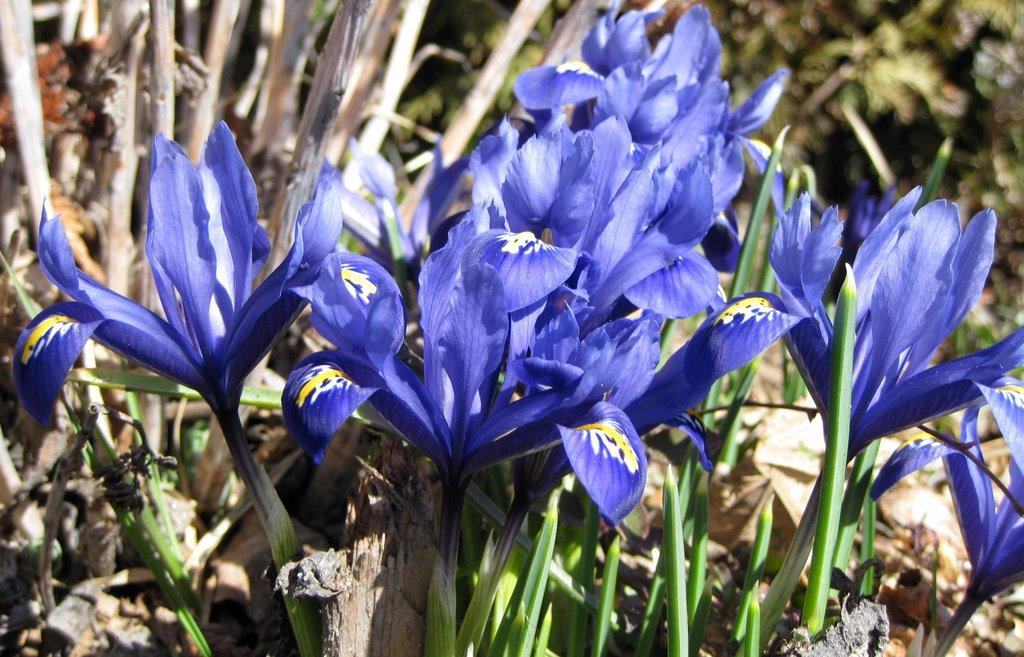What type of plants can be seen in the front of the image? There are flowers in the front of the image. What can be observed in the background of the image? There is greenery in the background of the image. How many cats are pushing the flowers in the image? There are no cats or pushing actions present in the image; it features flowers in the front and greenery in the background. What type of bears can be seen interacting with the greenery in the image? There are no bears present in the image; it only features flowers in the front and greenery in the background. 